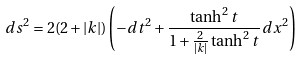<formula> <loc_0><loc_0><loc_500><loc_500>d s ^ { 2 } = 2 ( 2 + | k | ) \left ( - d t ^ { 2 } + \frac { \tanh ^ { 2 } t } { 1 + \frac { 2 } { | k | } \tanh ^ { 2 } t } \, d x ^ { 2 } \right )</formula> 